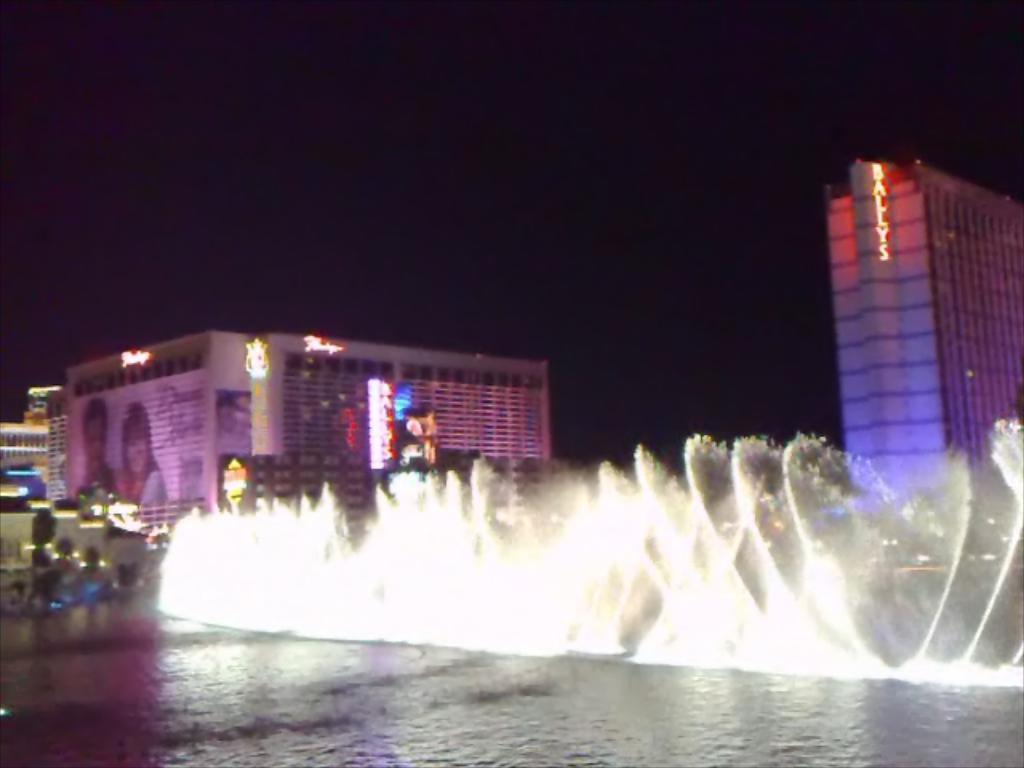What is the main subject in the middle of the image? There is a water fountain in the middle of the image. What can be seen at the bottom of the image? There is water at the bottom of the image. What type of structures are visible in the background of the image? There are buildings, posters, screens, and lights in the background of the image. What type of natural elements are visible in the background of the image? There are plants and the sky visible in the background of the image. How long does it take for the water fountain to change colors in the image? The image does not provide information about the water fountain changing colors, so it is not possible to determine how long it takes. 